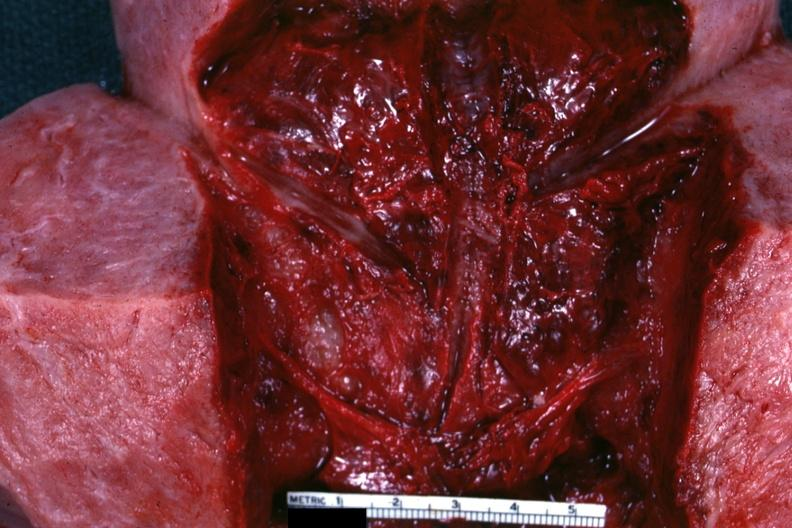where does this belong to?
Answer the question using a single word or phrase. Female reproductive system 